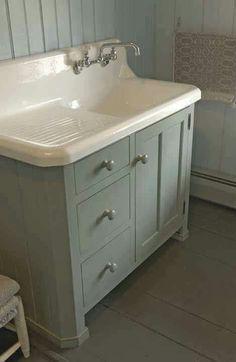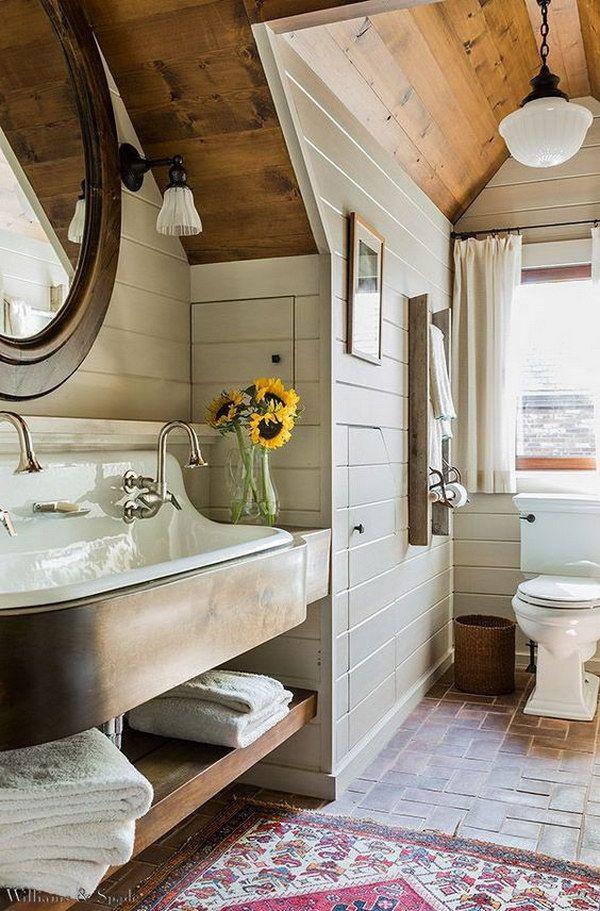The first image is the image on the left, the second image is the image on the right. For the images displayed, is the sentence "At least two rolls of toilet paper are in a container and near a sink." factually correct? Answer yes or no. No. The first image is the image on the left, the second image is the image on the right. For the images displayed, is the sentence "A row of three saucer shape lights are suspended above a mirror and sink." factually correct? Answer yes or no. No. 